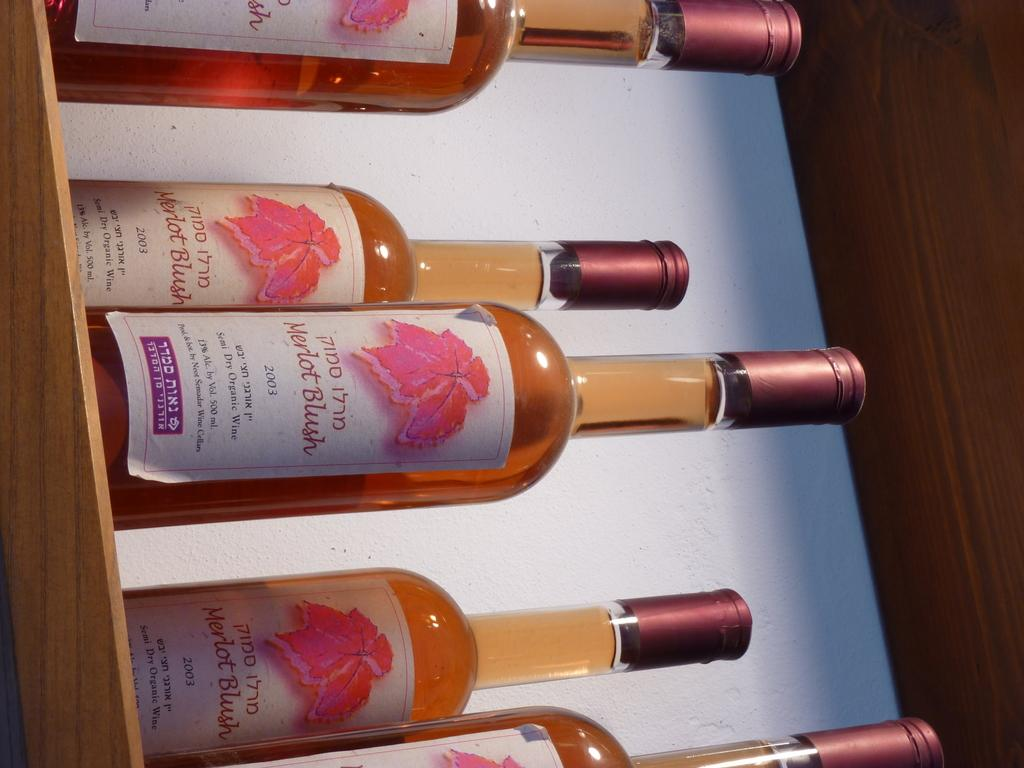<image>
Summarize the visual content of the image. Five bottles of 2003 Merlot Blush are on a shelf. 